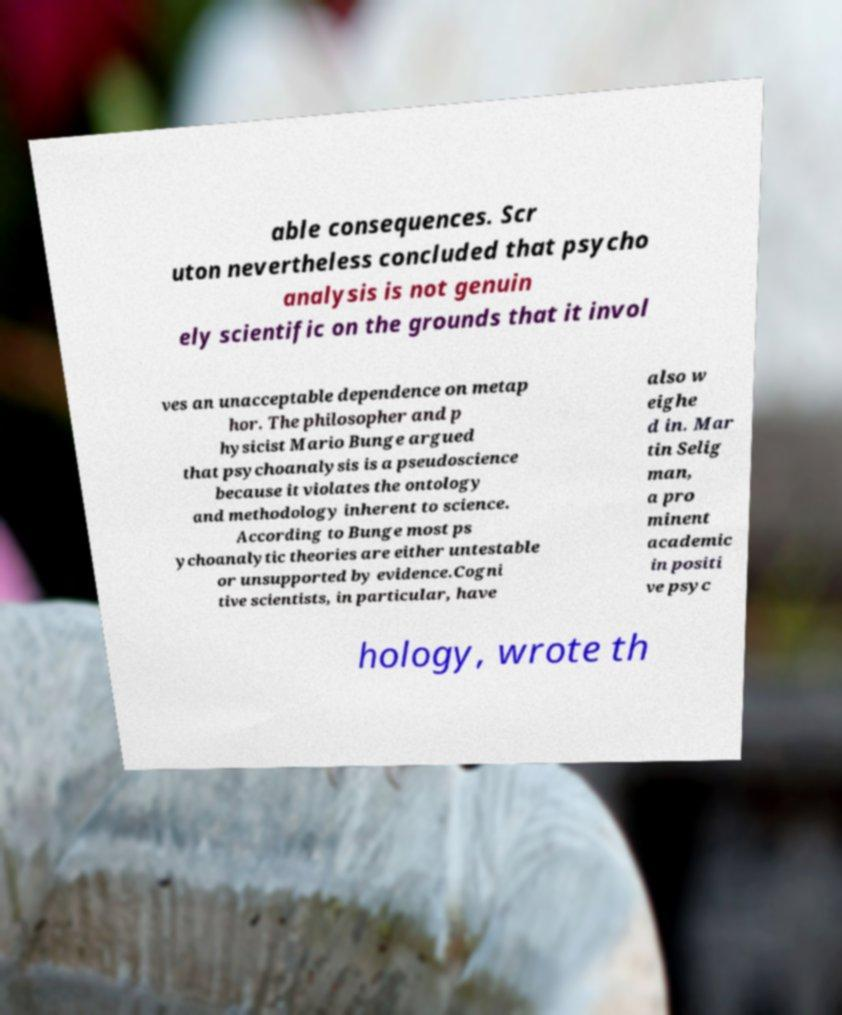Can you read and provide the text displayed in the image?This photo seems to have some interesting text. Can you extract and type it out for me? able consequences. Scr uton nevertheless concluded that psycho analysis is not genuin ely scientific on the grounds that it invol ves an unacceptable dependence on metap hor. The philosopher and p hysicist Mario Bunge argued that psychoanalysis is a pseudoscience because it violates the ontology and methodology inherent to science. According to Bunge most ps ychoanalytic theories are either untestable or unsupported by evidence.Cogni tive scientists, in particular, have also w eighe d in. Mar tin Selig man, a pro minent academic in positi ve psyc hology, wrote th 